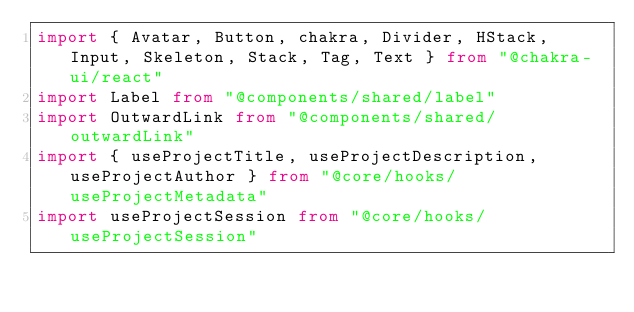<code> <loc_0><loc_0><loc_500><loc_500><_TypeScript_>import { Avatar, Button, chakra, Divider, HStack, Input, Skeleton, Stack, Tag, Text } from "@chakra-ui/react"
import Label from "@components/shared/label"
import OutwardLink from "@components/shared/outwardLink"
import { useProjectTitle, useProjectDescription, useProjectAuthor } from "@core/hooks/useProjectMetadata"
import useProjectSession from "@core/hooks/useProjectSession"</code> 